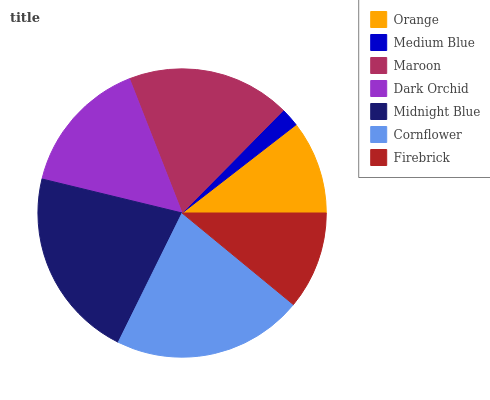Is Medium Blue the minimum?
Answer yes or no. Yes. Is Midnight Blue the maximum?
Answer yes or no. Yes. Is Maroon the minimum?
Answer yes or no. No. Is Maroon the maximum?
Answer yes or no. No. Is Maroon greater than Medium Blue?
Answer yes or no. Yes. Is Medium Blue less than Maroon?
Answer yes or no. Yes. Is Medium Blue greater than Maroon?
Answer yes or no. No. Is Maroon less than Medium Blue?
Answer yes or no. No. Is Dark Orchid the high median?
Answer yes or no. Yes. Is Dark Orchid the low median?
Answer yes or no. Yes. Is Orange the high median?
Answer yes or no. No. Is Orange the low median?
Answer yes or no. No. 